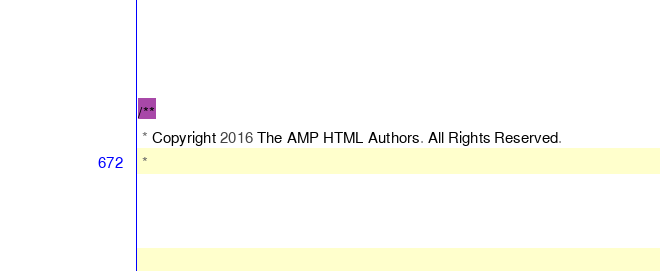Convert code to text. <code><loc_0><loc_0><loc_500><loc_500><_JavaScript_>/**
 * Copyright 2016 The AMP HTML Authors. All Rights Reserved.
 *</code> 